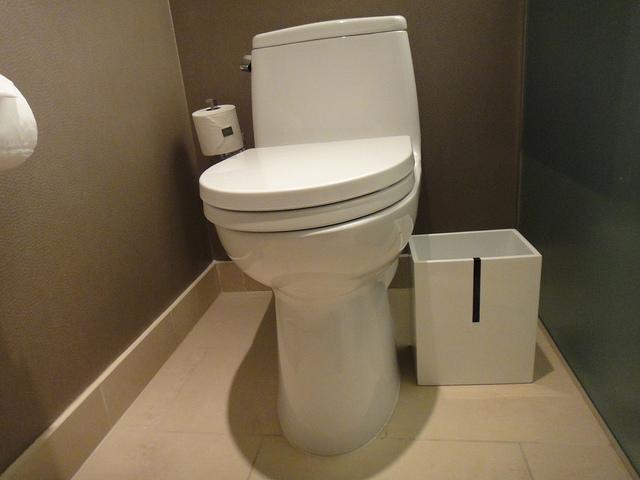How many rolls of toilet paper in this scene?
Write a very short answer. 2. Is this bathroom small?
Give a very brief answer. Yes. Is there toilet tissue?
Quick response, please. Yes. Is the toilet lid closed?
Concise answer only. Yes. Where is the most likely place that toilet paper is stored?
Keep it brief. Bathroom. What color is the toilet lid?
Short answer required. White. 